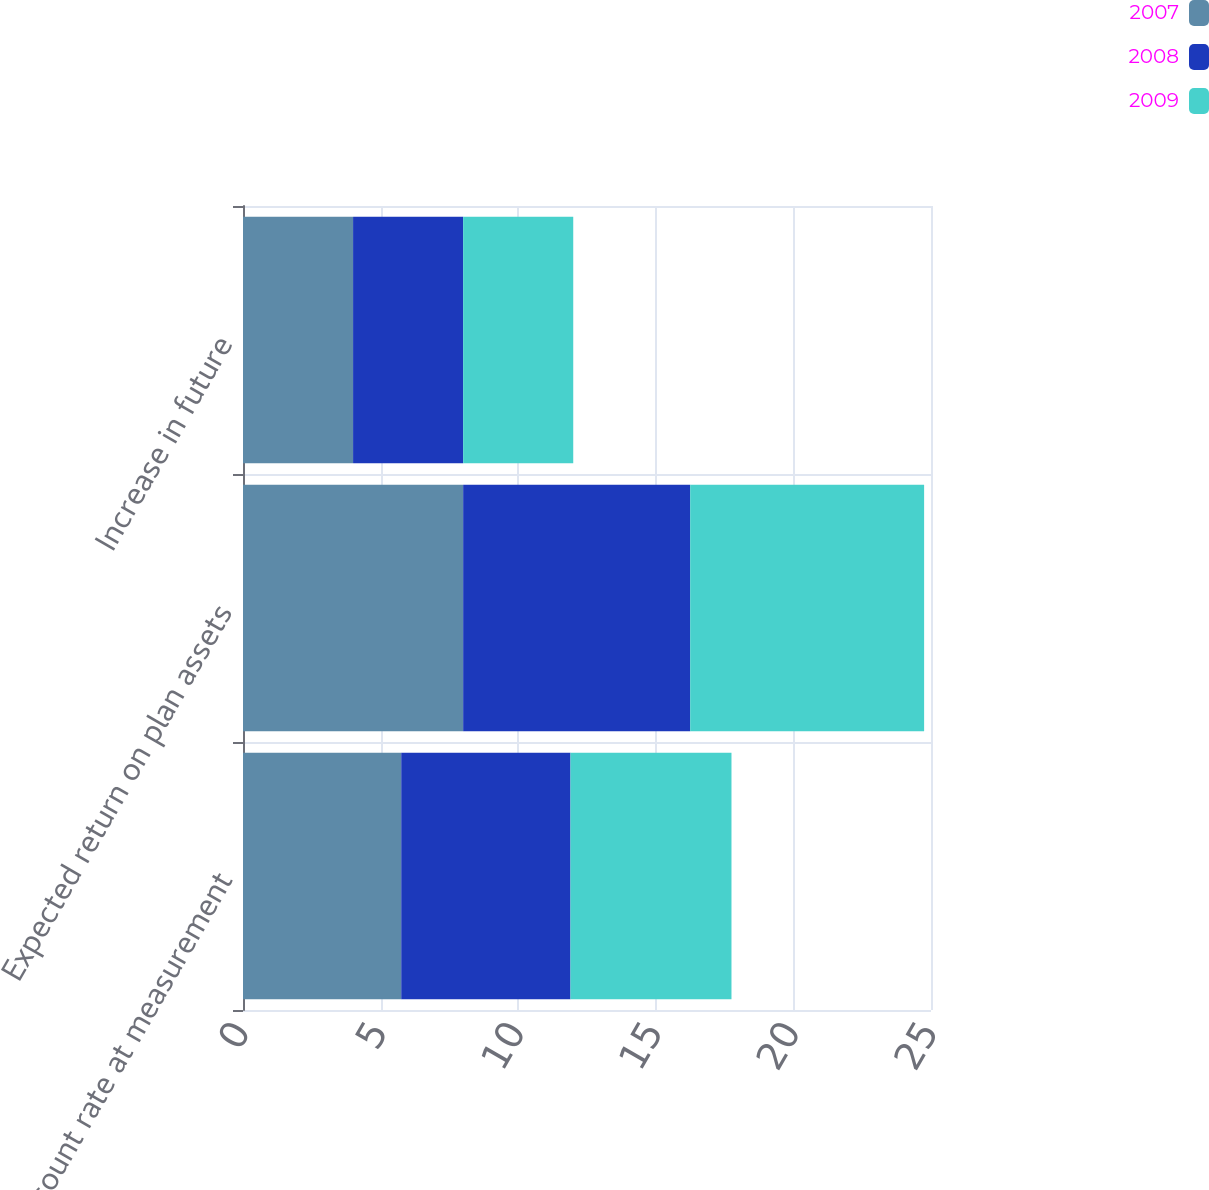<chart> <loc_0><loc_0><loc_500><loc_500><stacked_bar_chart><ecel><fcel>Discount rate at measurement<fcel>Expected return on plan assets<fcel>Increase in future<nl><fcel>2007<fcel>5.75<fcel>8<fcel>4<nl><fcel>2008<fcel>6.15<fcel>8.25<fcel>4<nl><fcel>2009<fcel>5.85<fcel>8.5<fcel>4<nl></chart> 